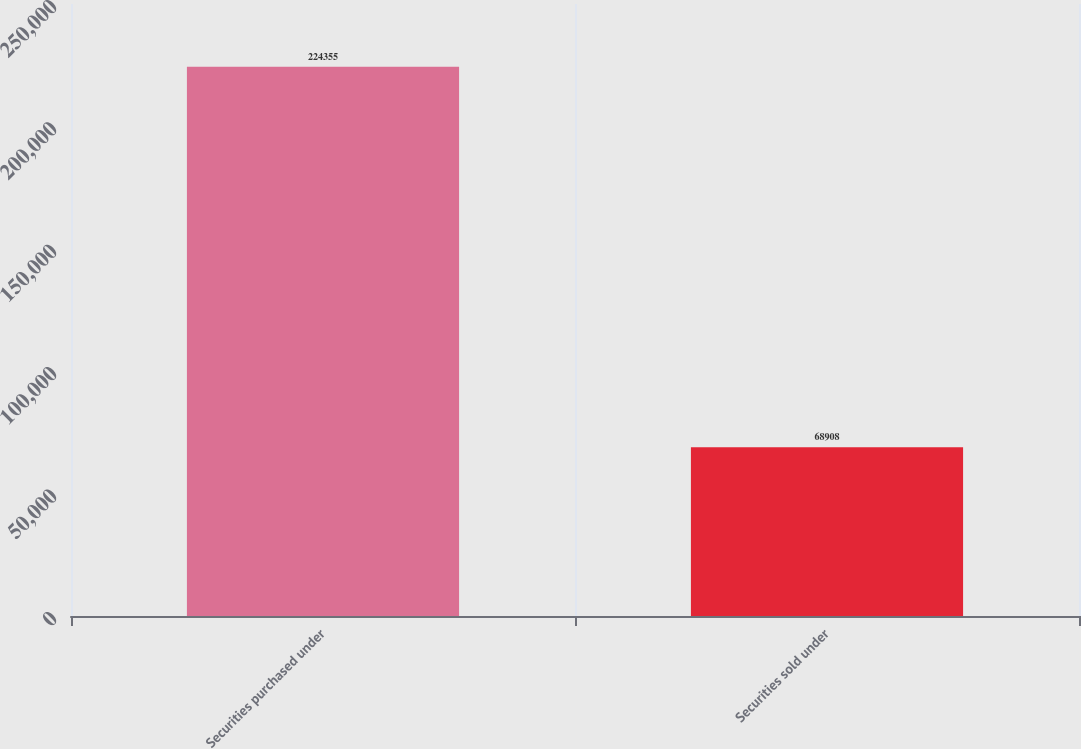<chart> <loc_0><loc_0><loc_500><loc_500><bar_chart><fcel>Securities purchased under<fcel>Securities sold under<nl><fcel>224355<fcel>68908<nl></chart> 